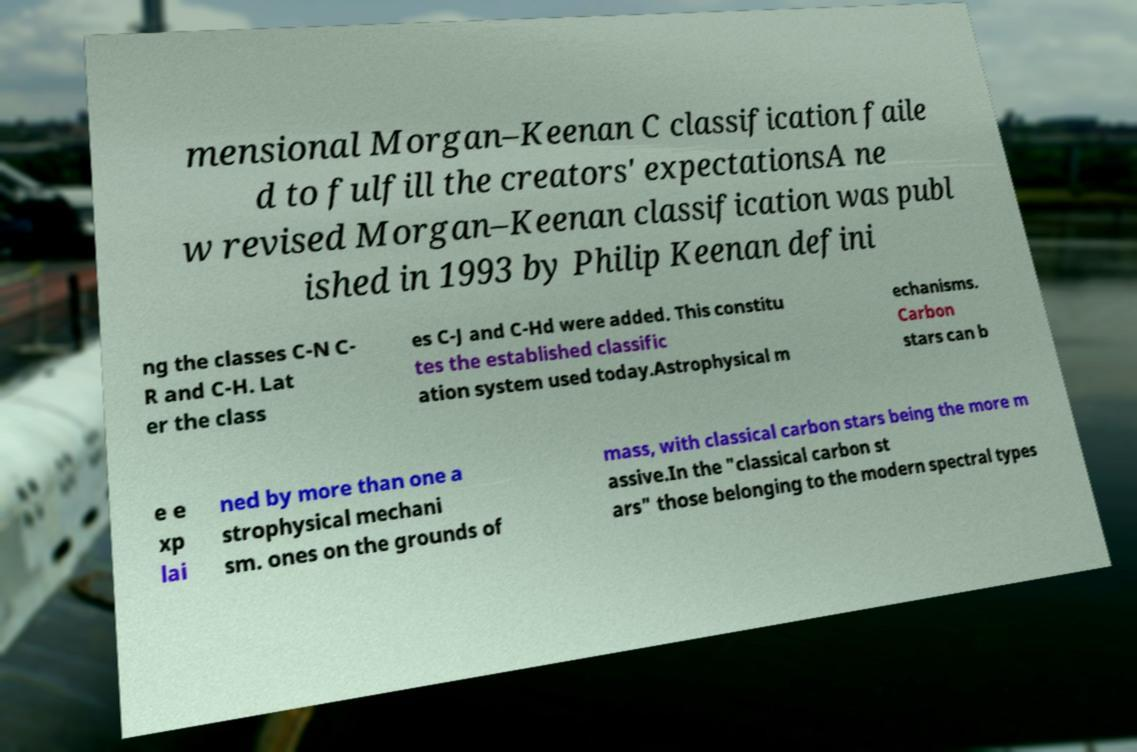Could you assist in decoding the text presented in this image and type it out clearly? mensional Morgan–Keenan C classification faile d to fulfill the creators' expectationsA ne w revised Morgan–Keenan classification was publ ished in 1993 by Philip Keenan defini ng the classes C-N C- R and C-H. Lat er the class es C-J and C-Hd were added. This constitu tes the established classific ation system used today.Astrophysical m echanisms. Carbon stars can b e e xp lai ned by more than one a strophysical mechani sm. ones on the grounds of mass, with classical carbon stars being the more m assive.In the "classical carbon st ars" those belonging to the modern spectral types 